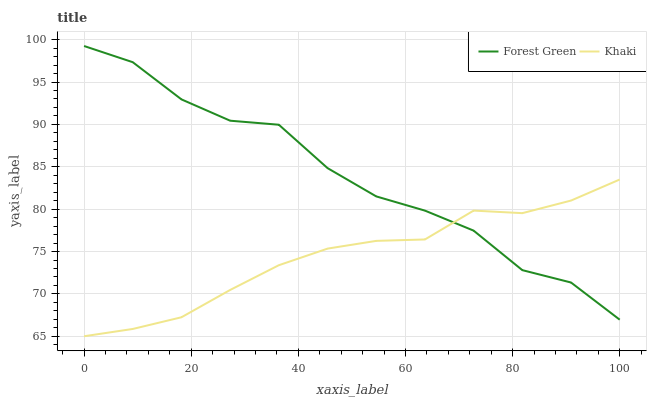Does Khaki have the minimum area under the curve?
Answer yes or no. Yes. Does Forest Green have the maximum area under the curve?
Answer yes or no. Yes. Does Khaki have the maximum area under the curve?
Answer yes or no. No. Is Khaki the smoothest?
Answer yes or no. Yes. Is Forest Green the roughest?
Answer yes or no. Yes. Is Khaki the roughest?
Answer yes or no. No. Does Khaki have the highest value?
Answer yes or no. No. 